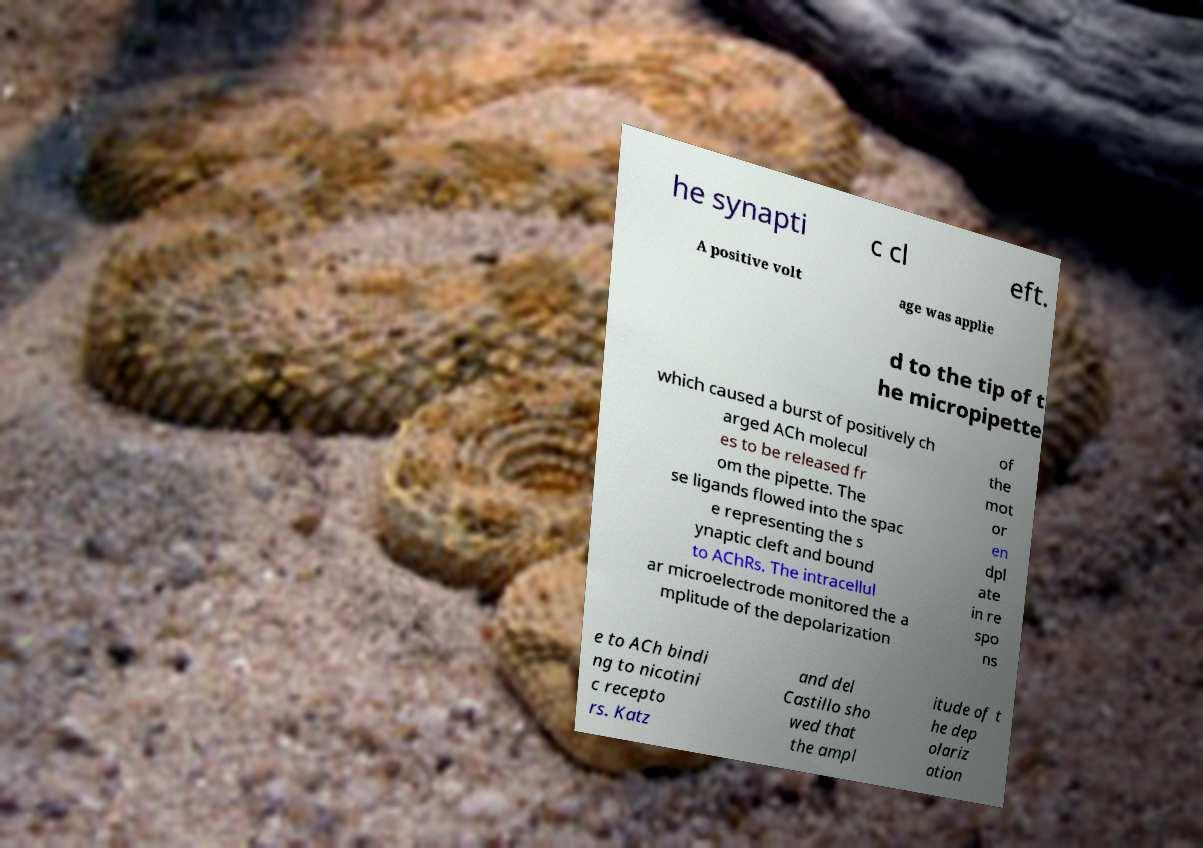Please identify and transcribe the text found in this image. he synapti c cl eft. A positive volt age was applie d to the tip of t he micropipette which caused a burst of positively ch arged ACh molecul es to be released fr om the pipette. The se ligands flowed into the spac e representing the s ynaptic cleft and bound to AChRs. The intracellul ar microelectrode monitored the a mplitude of the depolarization of the mot or en dpl ate in re spo ns e to ACh bindi ng to nicotini c recepto rs. Katz and del Castillo sho wed that the ampl itude of t he dep olariz ation 